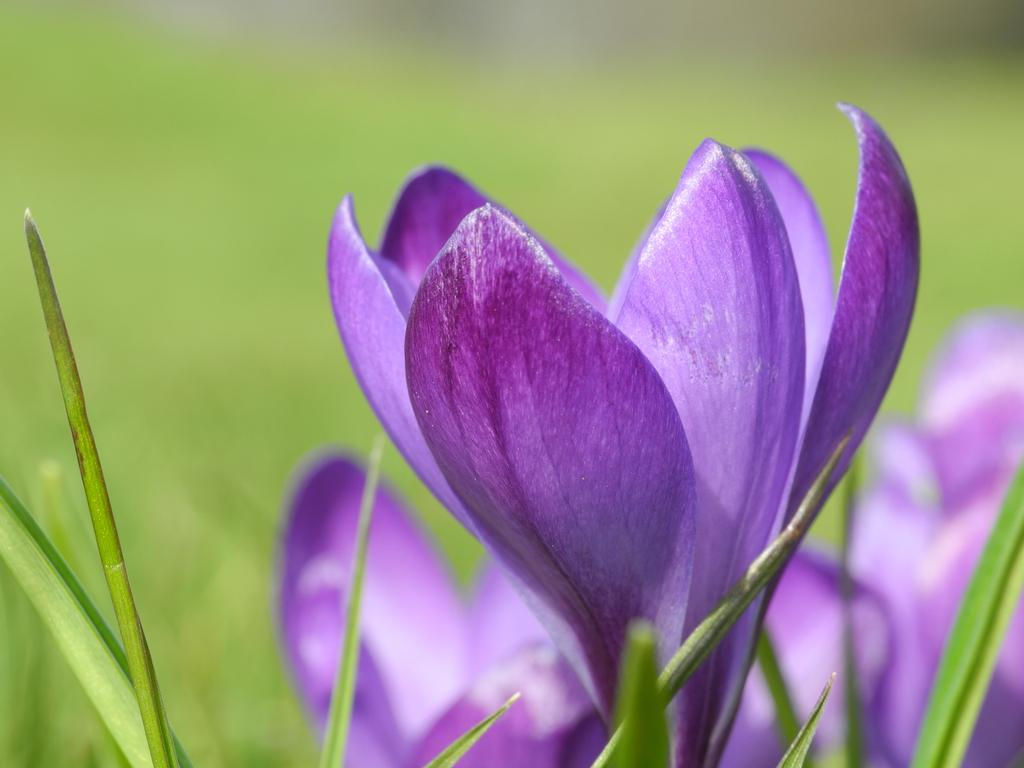What is the focus of the image? The image is zoomed in, so the focus is on the details in the foreground. What can be seen in the foreground of the image? There are flowers and leaves of a plant in the foreground of the image. How would you describe the background of the image? The background of the image is blurry and has a green color. What type of cactus can be smelled in the image? There is no cactus present in the image, and therefore no smell can be associated with it. 